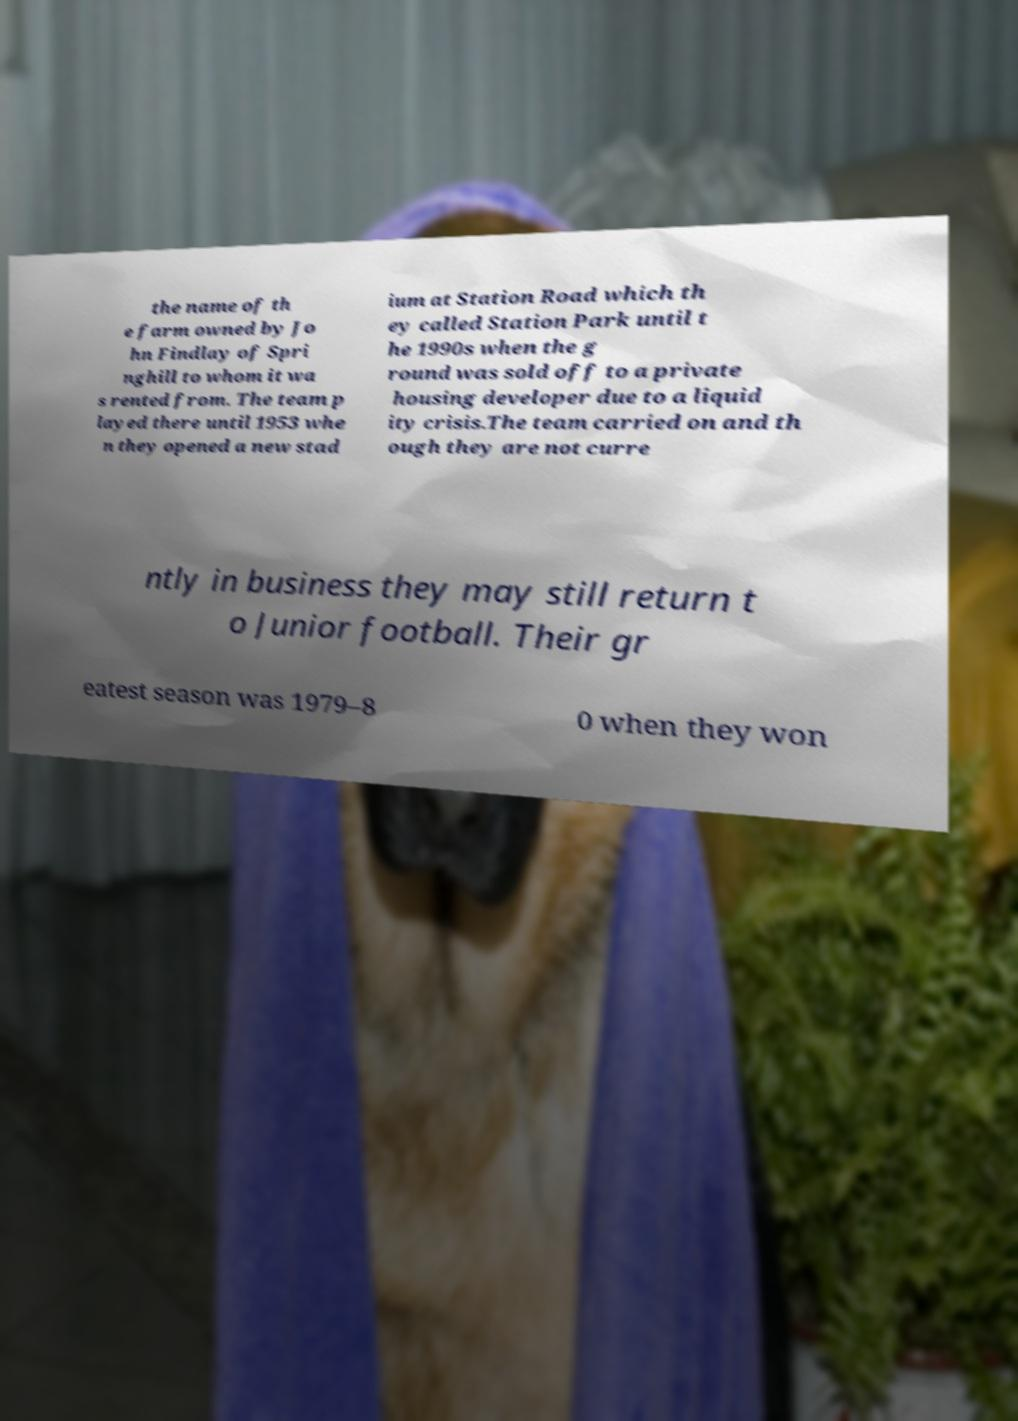Can you read and provide the text displayed in the image?This photo seems to have some interesting text. Can you extract and type it out for me? the name of th e farm owned by Jo hn Findlay of Spri nghill to whom it wa s rented from. The team p layed there until 1953 whe n they opened a new stad ium at Station Road which th ey called Station Park until t he 1990s when the g round was sold off to a private housing developer due to a liquid ity crisis.The team carried on and th ough they are not curre ntly in business they may still return t o Junior football. Their gr eatest season was 1979–8 0 when they won 